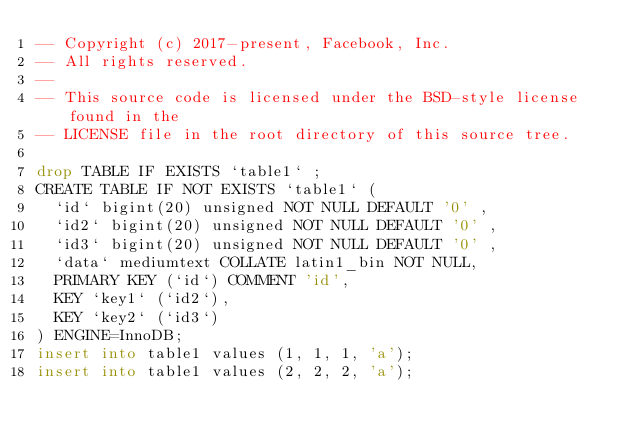<code> <loc_0><loc_0><loc_500><loc_500><_SQL_>-- Copyright (c) 2017-present, Facebook, Inc.
-- All rights reserved.
-- 
-- This source code is licensed under the BSD-style license found in the
-- LICENSE file in the root directory of this source tree.

drop TABLE IF EXISTS `table1` ;
CREATE TABLE IF NOT EXISTS `table1` (
  `id` bigint(20) unsigned NOT NULL DEFAULT '0' ,
  `id2` bigint(20) unsigned NOT NULL DEFAULT '0' ,
  `id3` bigint(20) unsigned NOT NULL DEFAULT '0' ,
  `data` mediumtext COLLATE latin1_bin NOT NULL,
  PRIMARY KEY (`id`) COMMENT 'id',
  KEY `key1` (`id2`),
  KEY `key2` (`id3`)
) ENGINE=InnoDB;
insert into table1 values (1, 1, 1, 'a');
insert into table1 values (2, 2, 2, 'a');
</code> 